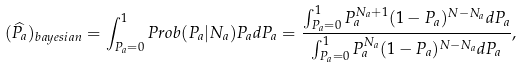<formula> <loc_0><loc_0><loc_500><loc_500>( \widehat { P _ { a } } ) _ { b a y e s i a n } = \int _ { P _ { a } = 0 } ^ { 1 } P r o b ( P _ { a } | N _ { a } ) P _ { a } d P _ { a } = \frac { \int _ { P _ { a } = 0 } ^ { 1 } P _ { a } ^ { N _ { a } + 1 } ( 1 - P _ { a } ) ^ { N - N _ { a } } d P _ { a } } { \int _ { P _ { a } = 0 } ^ { 1 } P _ { a } ^ { N _ { a } } ( 1 - P _ { a } ) ^ { N - N _ { a } } d P _ { a } } ,</formula> 